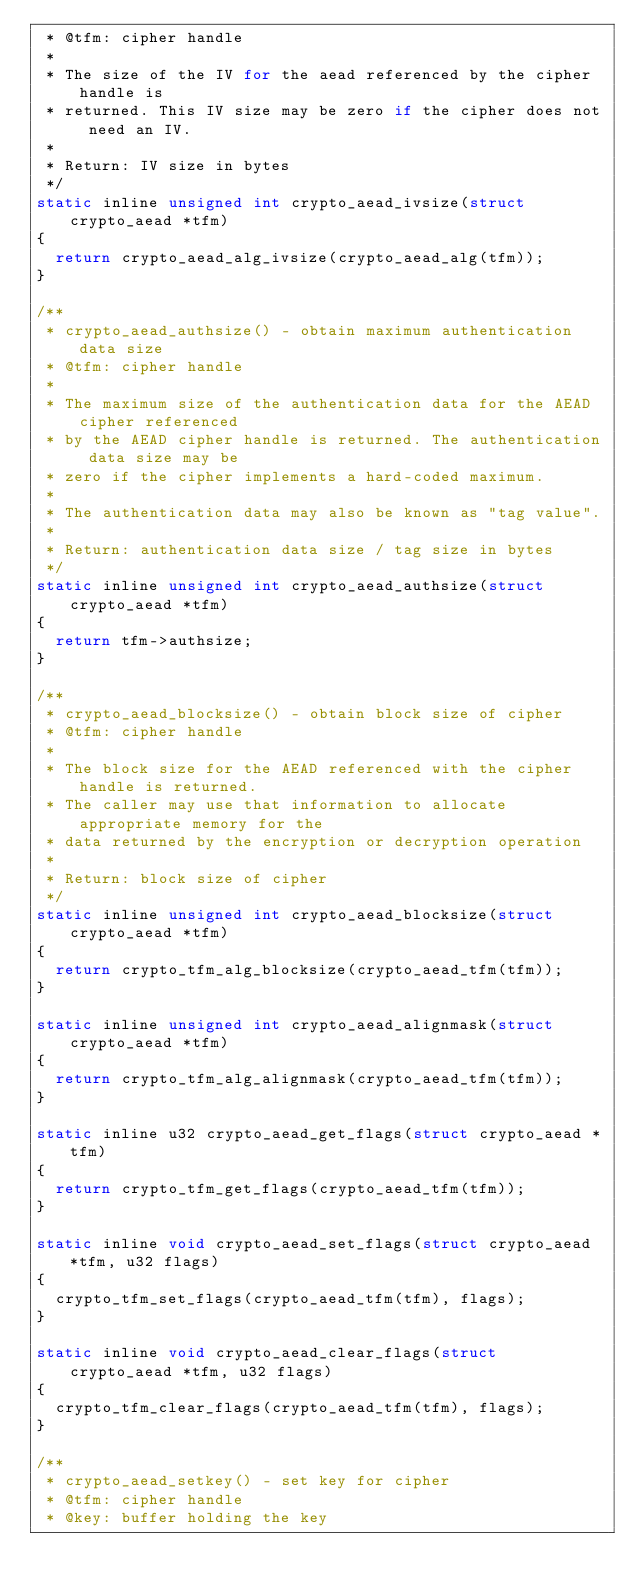<code> <loc_0><loc_0><loc_500><loc_500><_C_> * @tfm: cipher handle
 *
 * The size of the IV for the aead referenced by the cipher handle is
 * returned. This IV size may be zero if the cipher does not need an IV.
 *
 * Return: IV size in bytes
 */
static inline unsigned int crypto_aead_ivsize(struct crypto_aead *tfm)
{
	return crypto_aead_alg_ivsize(crypto_aead_alg(tfm));
}

/**
 * crypto_aead_authsize() - obtain maximum authentication data size
 * @tfm: cipher handle
 *
 * The maximum size of the authentication data for the AEAD cipher referenced
 * by the AEAD cipher handle is returned. The authentication data size may be
 * zero if the cipher implements a hard-coded maximum.
 *
 * The authentication data may also be known as "tag value".
 *
 * Return: authentication data size / tag size in bytes
 */
static inline unsigned int crypto_aead_authsize(struct crypto_aead *tfm)
{
	return tfm->authsize;
}

/**
 * crypto_aead_blocksize() - obtain block size of cipher
 * @tfm: cipher handle
 *
 * The block size for the AEAD referenced with the cipher handle is returned.
 * The caller may use that information to allocate appropriate memory for the
 * data returned by the encryption or decryption operation
 *
 * Return: block size of cipher
 */
static inline unsigned int crypto_aead_blocksize(struct crypto_aead *tfm)
{
	return crypto_tfm_alg_blocksize(crypto_aead_tfm(tfm));
}

static inline unsigned int crypto_aead_alignmask(struct crypto_aead *tfm)
{
	return crypto_tfm_alg_alignmask(crypto_aead_tfm(tfm));
}

static inline u32 crypto_aead_get_flags(struct crypto_aead *tfm)
{
	return crypto_tfm_get_flags(crypto_aead_tfm(tfm));
}

static inline void crypto_aead_set_flags(struct crypto_aead *tfm, u32 flags)
{
	crypto_tfm_set_flags(crypto_aead_tfm(tfm), flags);
}

static inline void crypto_aead_clear_flags(struct crypto_aead *tfm, u32 flags)
{
	crypto_tfm_clear_flags(crypto_aead_tfm(tfm), flags);
}

/**
 * crypto_aead_setkey() - set key for cipher
 * @tfm: cipher handle
 * @key: buffer holding the key</code> 